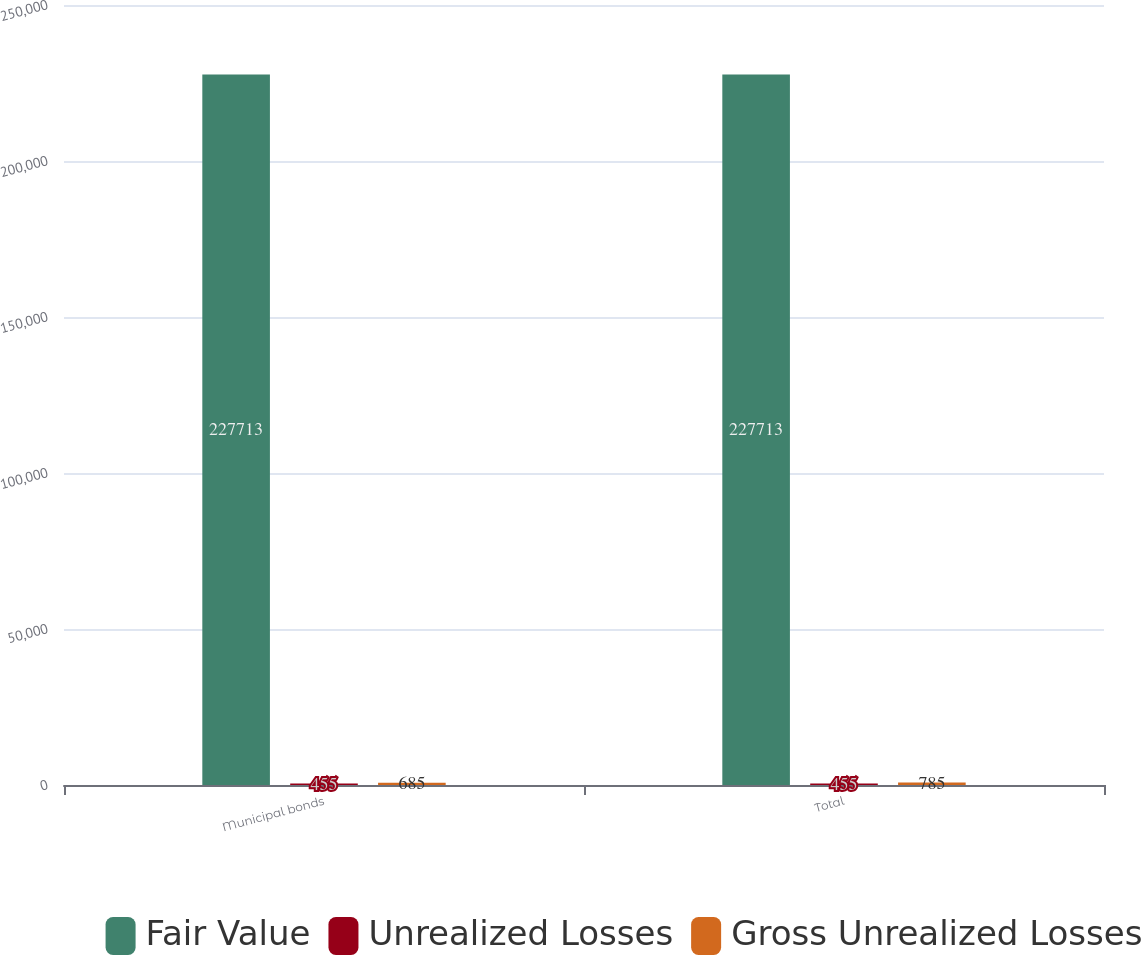<chart> <loc_0><loc_0><loc_500><loc_500><stacked_bar_chart><ecel><fcel>Municipal bonds<fcel>Total<nl><fcel>Fair Value<fcel>227713<fcel>227713<nl><fcel>Unrealized Losses<fcel>455<fcel>455<nl><fcel>Gross Unrealized Losses<fcel>685<fcel>785<nl></chart> 